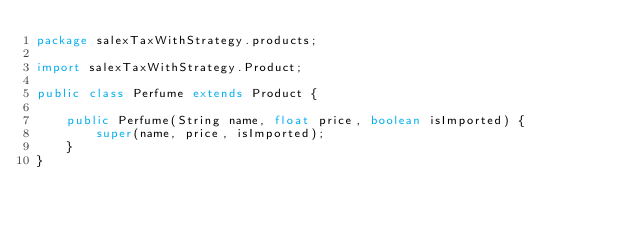<code> <loc_0><loc_0><loc_500><loc_500><_Java_>package salexTaxWithStrategy.products;

import salexTaxWithStrategy.Product;

public class Perfume extends Product {

    public Perfume(String name, float price, boolean isImported) {
        super(name, price, isImported);
    }
}
</code> 